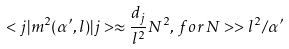<formula> <loc_0><loc_0><loc_500><loc_500>< j | m ^ { 2 } ( \alpha ^ { \prime } , l ) | j > \approx \frac { d _ { j } } { l ^ { 2 } } N ^ { 2 } , \, f o r \, N > > l ^ { 2 } / \alpha ^ { \prime }</formula> 